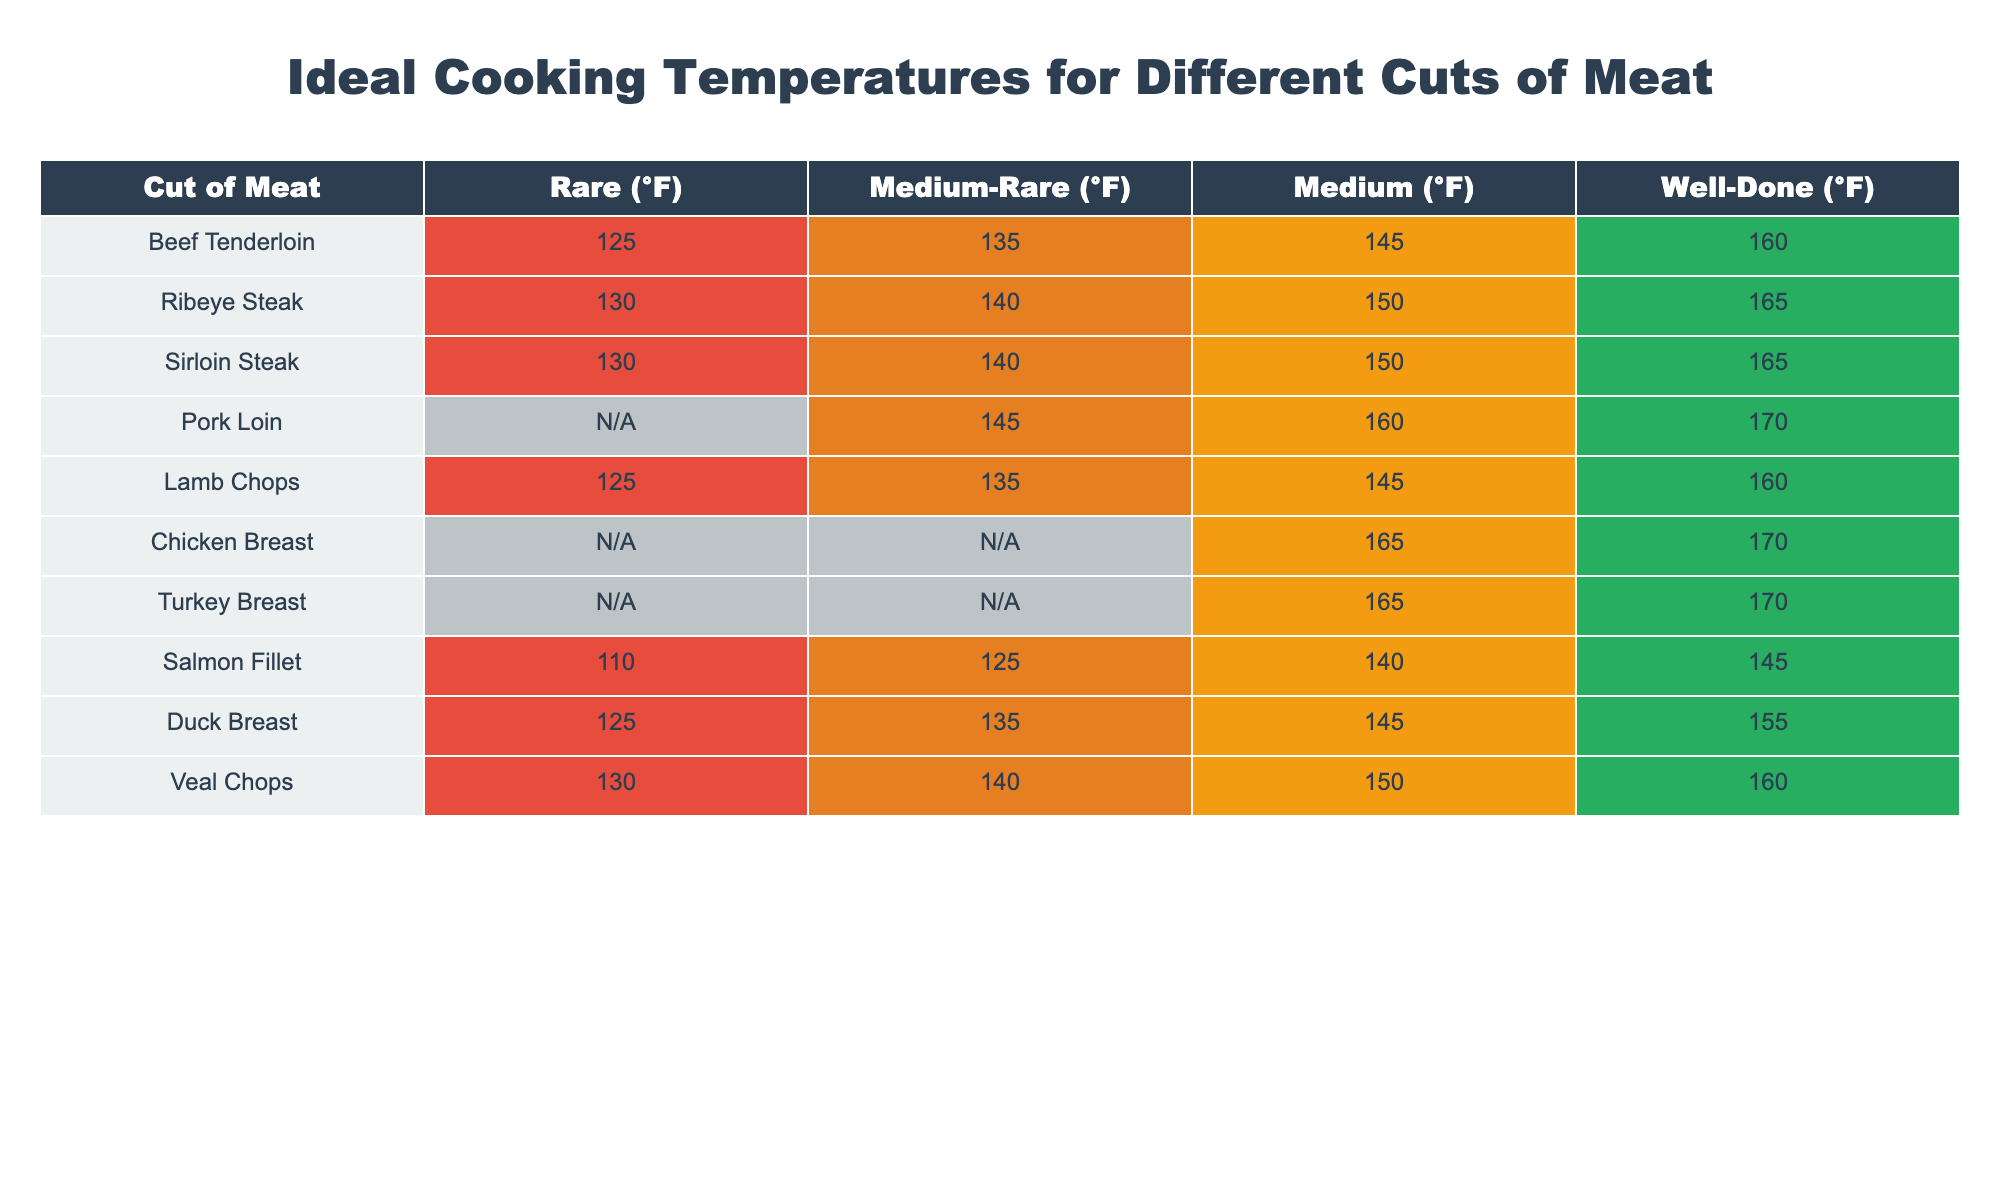What is the ideal cooking temperature for a Ribeye Steak when cooked medium? According to the table, the ideal cooking temperature for a Ribeye Steak at medium doneness is 150°F.
Answer: 150°F Is it true that chicken breast can be served medium-rare? Referring to the table, chicken breast does not have an ideal cooking temperature listed for medium-rare; it is marked as N/A. Therefore, it is false that chicken breast can be served medium-rare.
Answer: No What is the difference in temperature between Medium and Well-Done for Beef Tenderloin? The table indicates that the temperature for Medium Beef Tenderloin is 145°F and for Well-Done is 160°F. The difference is 160°F - 145°F = 15°F.
Answer: 15°F Which cuts of meat require a cooking temperature of at least 165°F? By examining the table, the cuts of meat with 165°F as their minimum cooking temperature are Chicken Breast (only at Well-Done), Turkey Breast (only at Well-Done), and pork loin (medium and well-done).
Answer: Chicken Breast, Turkey Breast, Pork Loin What is the average ideal cooking temperature for Lamb Chops across all doneness categories? For Lamb Chops, the cooking temperatures are 125°F (Rare), 135°F (Medium-Rare), 145°F (Medium), and 160°F (Well-Done). The average temperature is calculated as follows: (125 + 135 + 145 + 160) / 4 = 141.25°F.
Answer: 141.25°F 